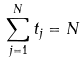Convert formula to latex. <formula><loc_0><loc_0><loc_500><loc_500>\sum _ { j = 1 } ^ { N } t _ { j } = N</formula> 